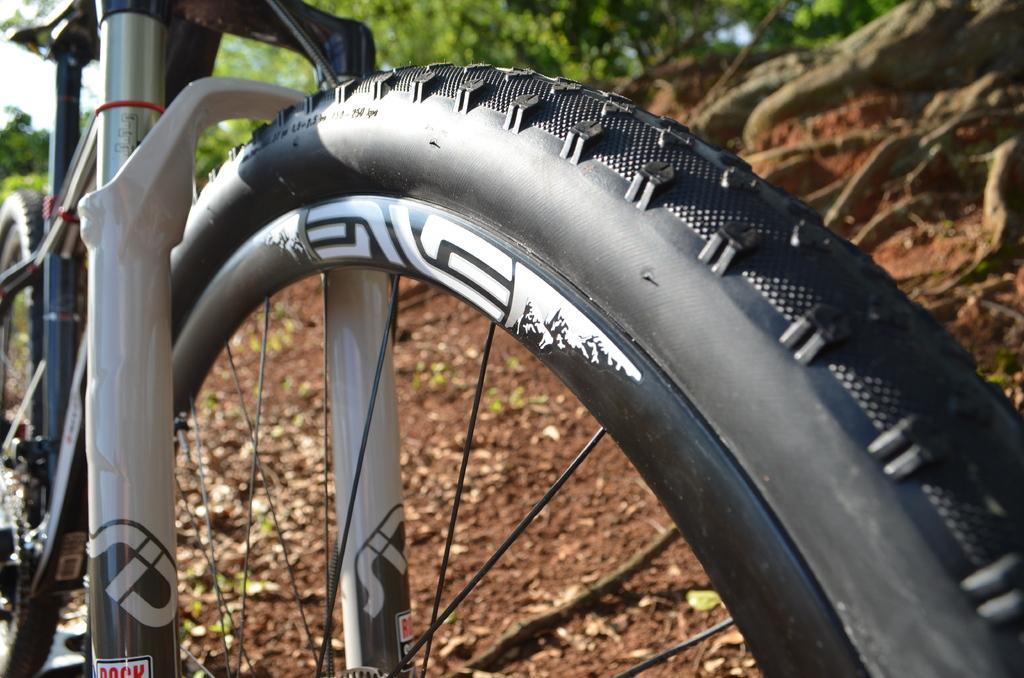Please provide a concise description of this image. In this image we can see a bicycle. Behind the cycle we can see the rocks and the trees. In the top left, we can see the sky. 